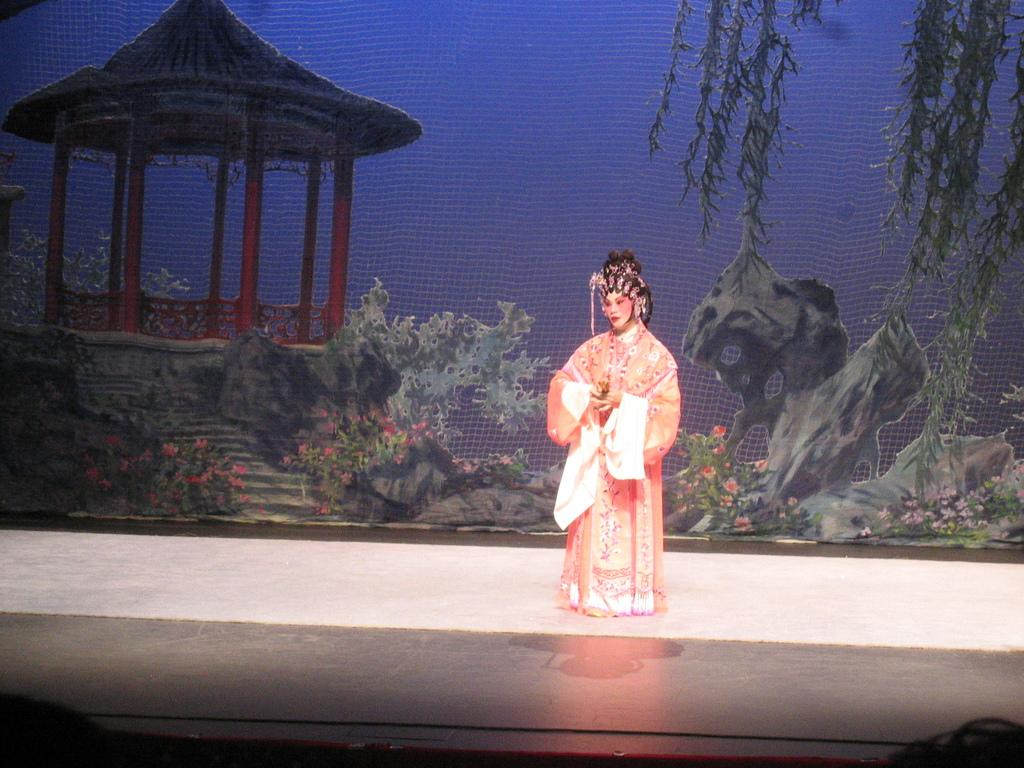What is happening in the image? There is a person standing on the stage. What can be seen behind the person on the stage? There is a wallpaper behind the person, which features images of plants, rocks, a hut with a roof, and poles. Can you describe the wallpaper in more detail? The wallpaper has images of plants, rocks, a hut with a roof, and poles. How many babies are crawling on the stage in the image? There are no babies present in the image; it only shows a person standing on the stage and a wallpaper with various images. 